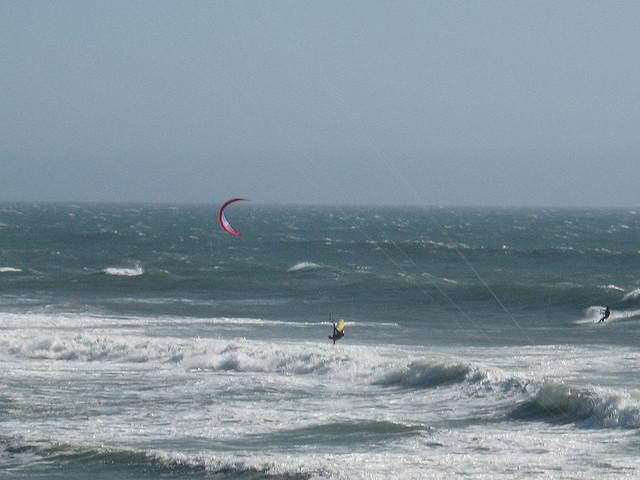Where is the person in the water?
Short answer required. Yes. What is the person doing in the water?
Give a very brief answer. Parasailing. Is the water calm?
Concise answer only. No. What is the color of the water?
Write a very short answer. Blue. 